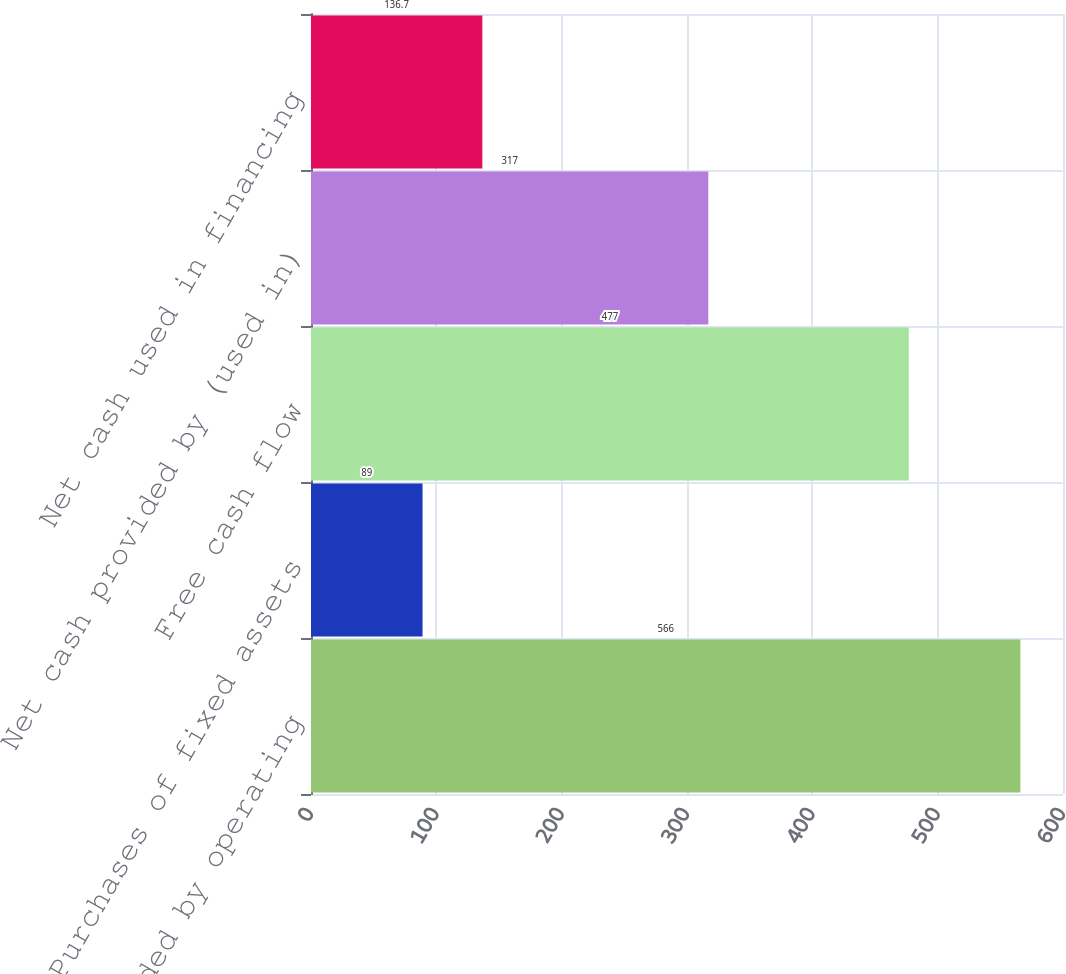Convert chart to OTSL. <chart><loc_0><loc_0><loc_500><loc_500><bar_chart><fcel>Net cash provided by operating<fcel>Purchases of fixed assets<fcel>Free cash flow<fcel>Net cash provided by (used in)<fcel>Net cash used in financing<nl><fcel>566<fcel>89<fcel>477<fcel>317<fcel>136.7<nl></chart> 